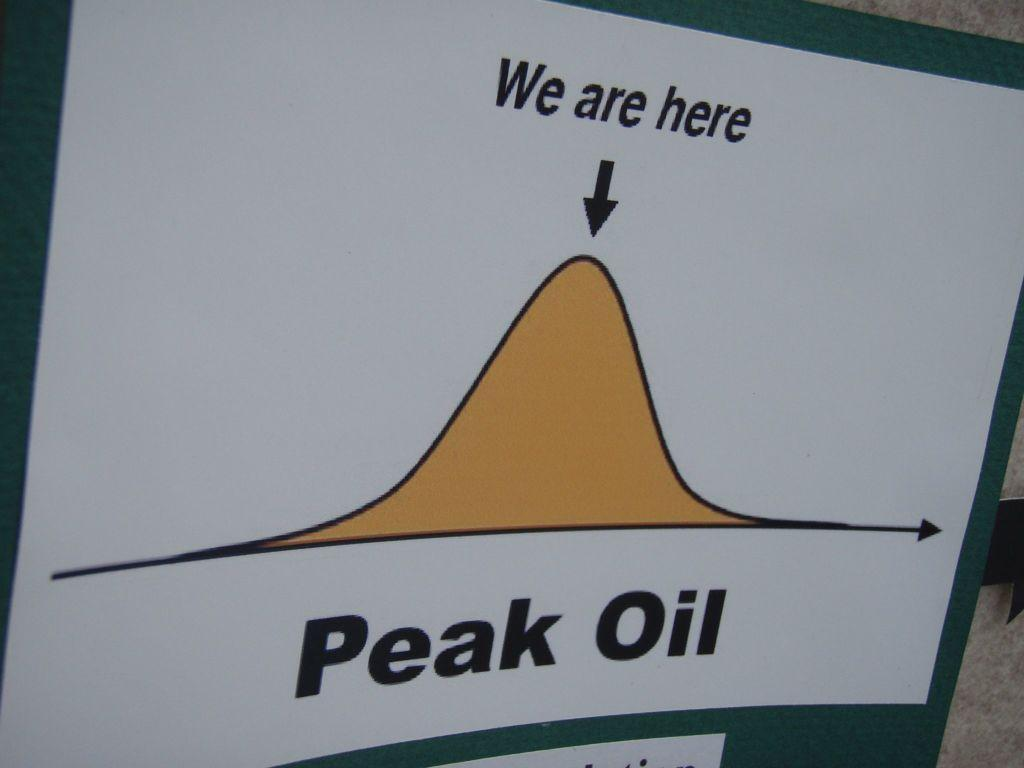<image>
Present a compact description of the photo's key features. a white sheet that has peak oil at the bottom 